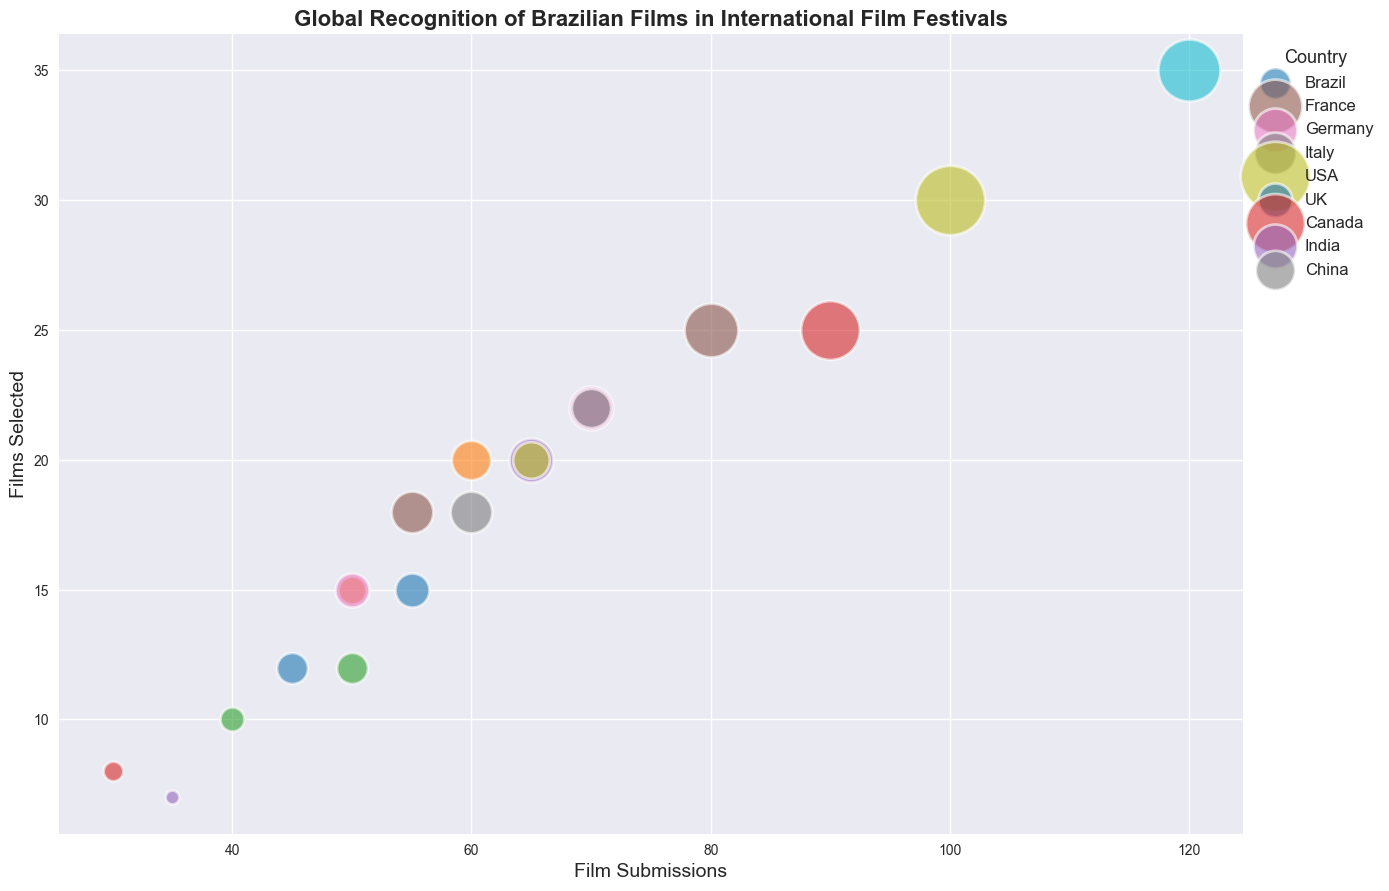Which country has the highest number of film submissions to international film festivals? By referring to the bubble chart, find the bubble that is farthest to the right, indicating the highest number of submissions. The USA has the bubble located at 120 submissions.
Answer: USA How many awards has Brazil won in total across all film festivals? Add the awards won at each film festival by Brazil. Cannes (5) + Berlin (4) + Venice (3) + Toronto (2) + Sundance (1) = 15 awards.
Answer: 15 Which film festival had the most films selected from India? Look at the bubbles for India and compare their heights on the y-axis. The Cannes Film Festival bubble for India is at the highest point, indicating 20 films selected.
Answer: Cannes Film Festival Between Brazil and France, which country had a higher ratio of awards won to films selected at the Cannes Film Festival? For Brazil: awards won (5) / films selected (12) ≈ 0.42. For France: awards won (15) / films selected (25) = 0.6. France has a higher ratio.
Answer: France What is the average number of films selected per submission for the UK at all film festivals? Calculate the average for the UK by summing the selected films and dividing by the submissions across all festivals attended by the UK: (15 + 20 + 12) / (55 + 60 + 50) = 47 / 165 ≈ 0.285.
Answer: 0.285 Which country has won the most awards at the Venice Film Festival? Check the size of the bubbles for Venice Film Festival and find the largest. Italy's bubble is the largest with 9 awards.
Answer: Italy Do more submissions typically result in more awards for Brazil? Compare the scatter points for Brazil across festivals. Generally, yes. Bubbles with more submissions (higher on the x-axis) such as Berlin and Cannes tend to correspond with more awards (larger bubbles).
Answer: Yes What is the total number of films selected from China at the Cannes and Berlin International Film Festivals combined? Add the films selected from both festivals for China: Cannes (22) + Berlin (20) = 42 films.
Answer: 42 Which country had more films selected at the Toronto International Film Festival: USA or Canada? Compare the heights of their bubbles on the y-axis. The USA bubble is at 30 and the Canada bubble is at 25.
Answer: USA Is there a correlation between the number of film submissions and the awards won for USA? Explain with the observed scatter points. Observe the bubbles for the USA: Toronto (100 submissions, 25 awards) and Sundance (120 submissions, 20 awards). Larger submissions generally correspond with larger awards, indicating a positive correlation.
Answer: Yes 